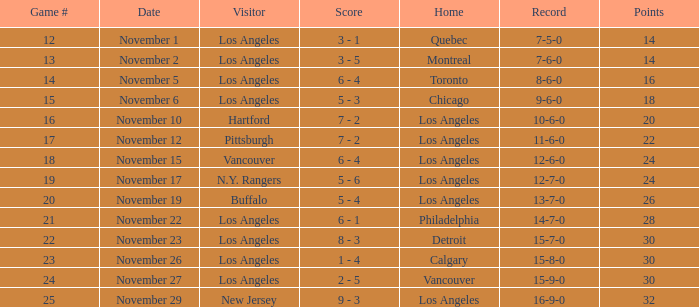What was the game's outcome on november 22? 14-7-0. 